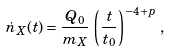Convert formula to latex. <formula><loc_0><loc_0><loc_500><loc_500>\dot { n } _ { X } ( t ) = \frac { Q _ { 0 } } { m _ { X } } \, \left ( \frac { t } { t _ { 0 } } \right ) ^ { - 4 + p } \, ,</formula> 